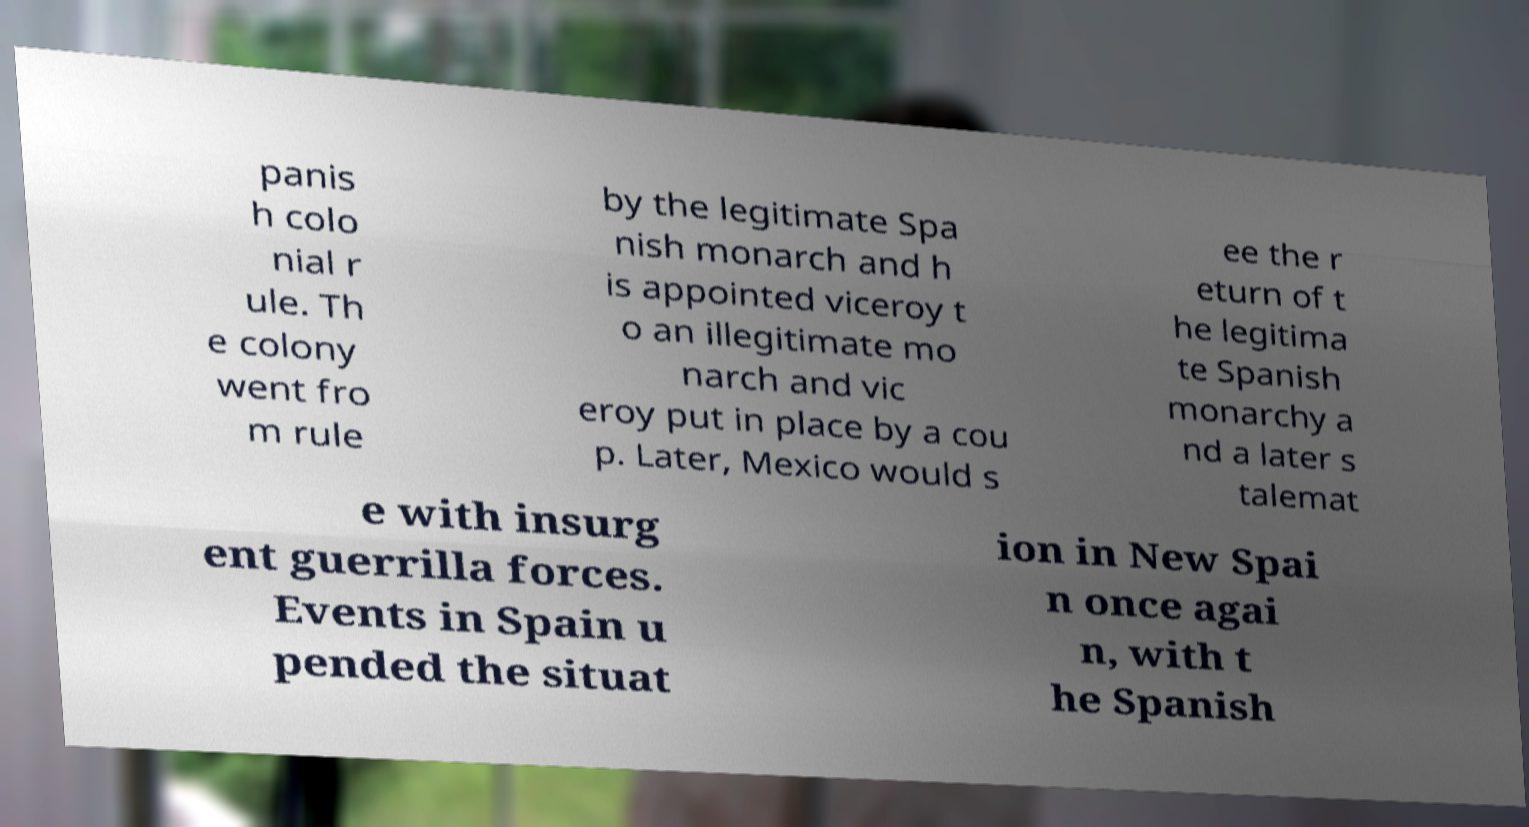For documentation purposes, I need the text within this image transcribed. Could you provide that? panis h colo nial r ule. Th e colony went fro m rule by the legitimate Spa nish monarch and h is appointed viceroy t o an illegitimate mo narch and vic eroy put in place by a cou p. Later, Mexico would s ee the r eturn of t he legitima te Spanish monarchy a nd a later s talemat e with insurg ent guerrilla forces. Events in Spain u pended the situat ion in New Spai n once agai n, with t he Spanish 